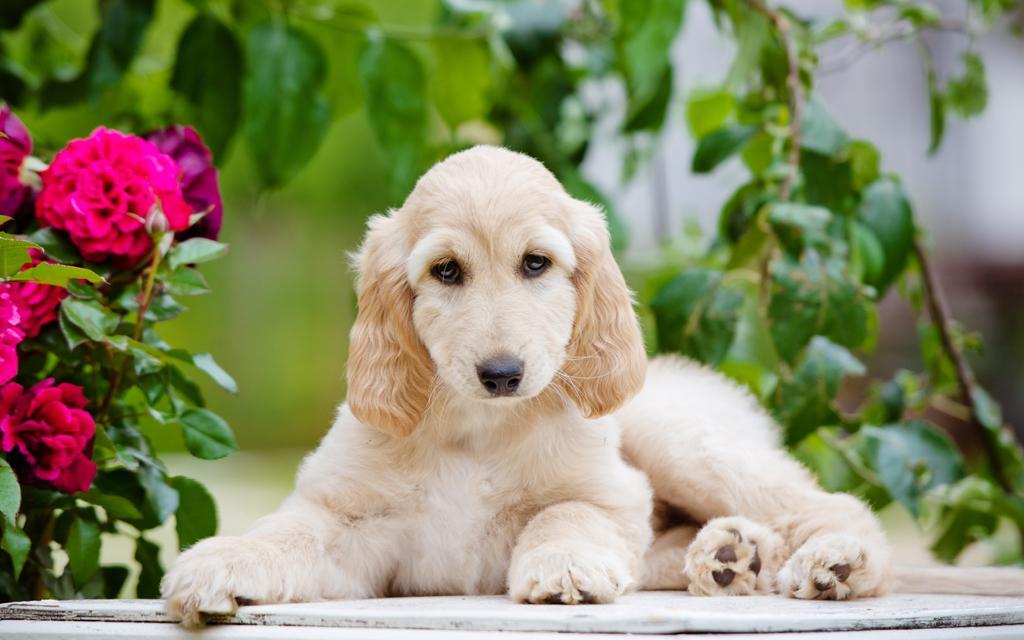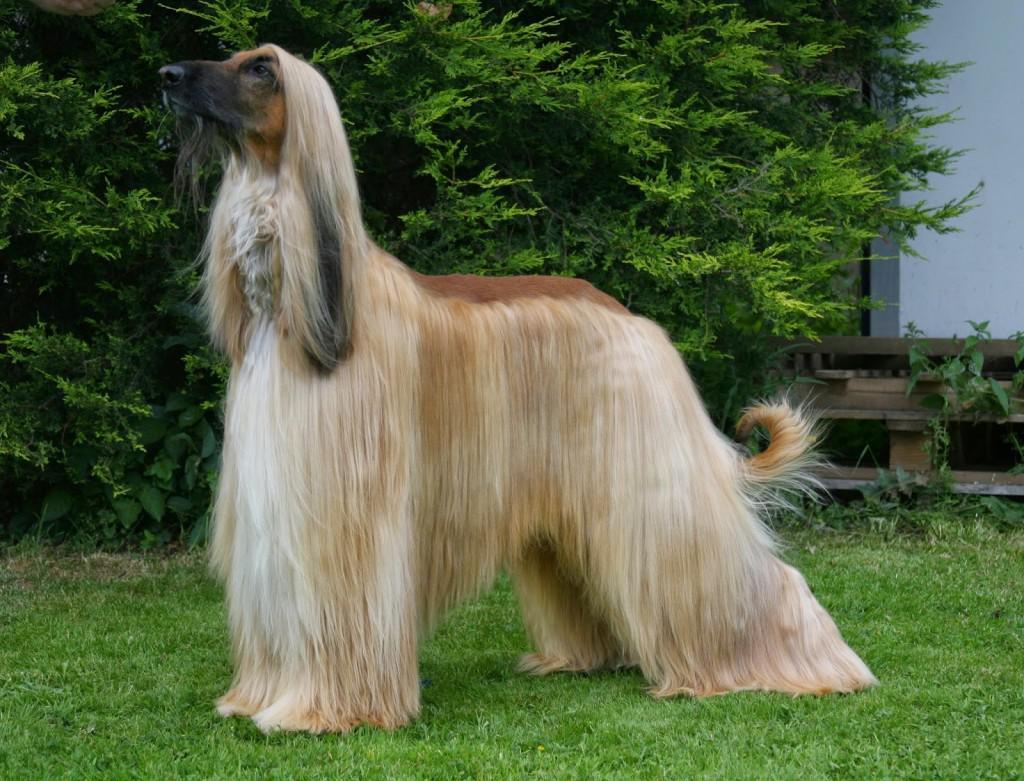The first image is the image on the left, the second image is the image on the right. Considering the images on both sides, is "One image contains at least five dogs, with varying fur coloration." valid? Answer yes or no. No. The first image is the image on the left, the second image is the image on the right. For the images displayed, is the sentence "There is a group of dogs in one of the images." factually correct? Answer yes or no. No. 